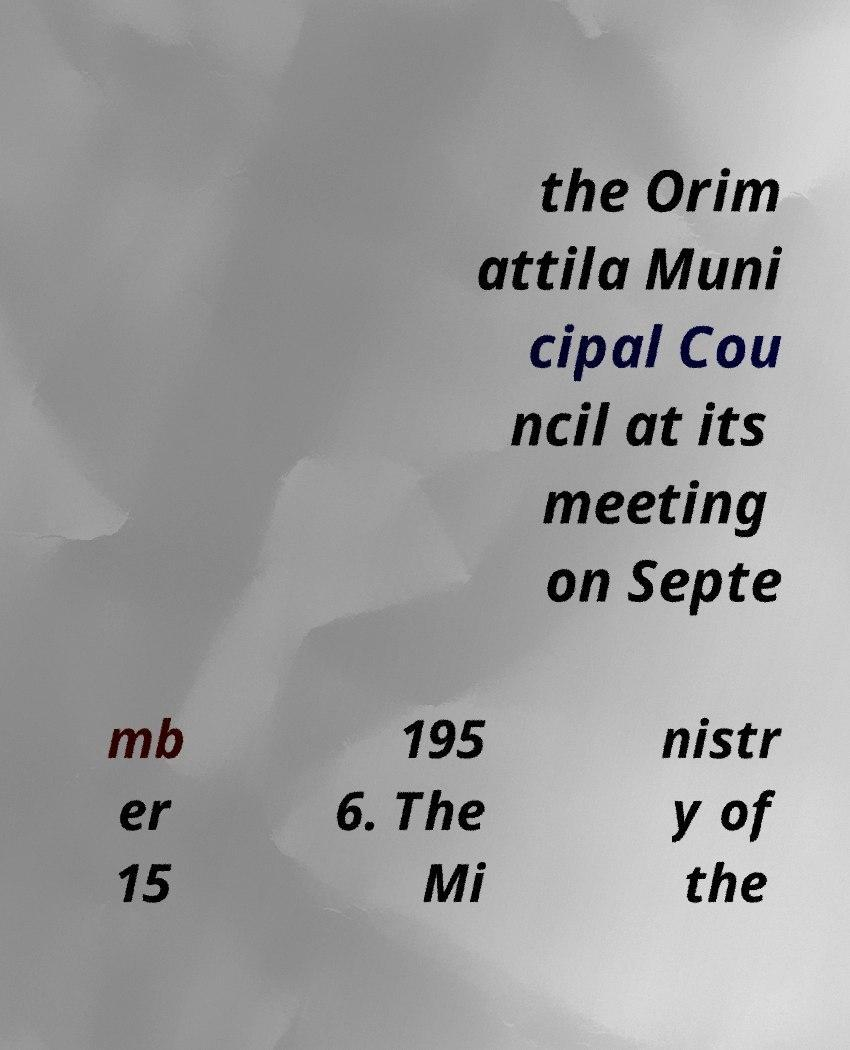Can you accurately transcribe the text from the provided image for me? the Orim attila Muni cipal Cou ncil at its meeting on Septe mb er 15 195 6. The Mi nistr y of the 